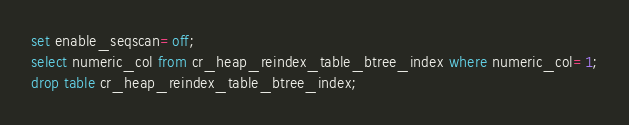Convert code to text. <code><loc_0><loc_0><loc_500><loc_500><_SQL_>
set enable_seqscan=off;
select numeric_col from cr_heap_reindex_table_btree_index where numeric_col=1;
drop table cr_heap_reindex_table_btree_index;
</code> 